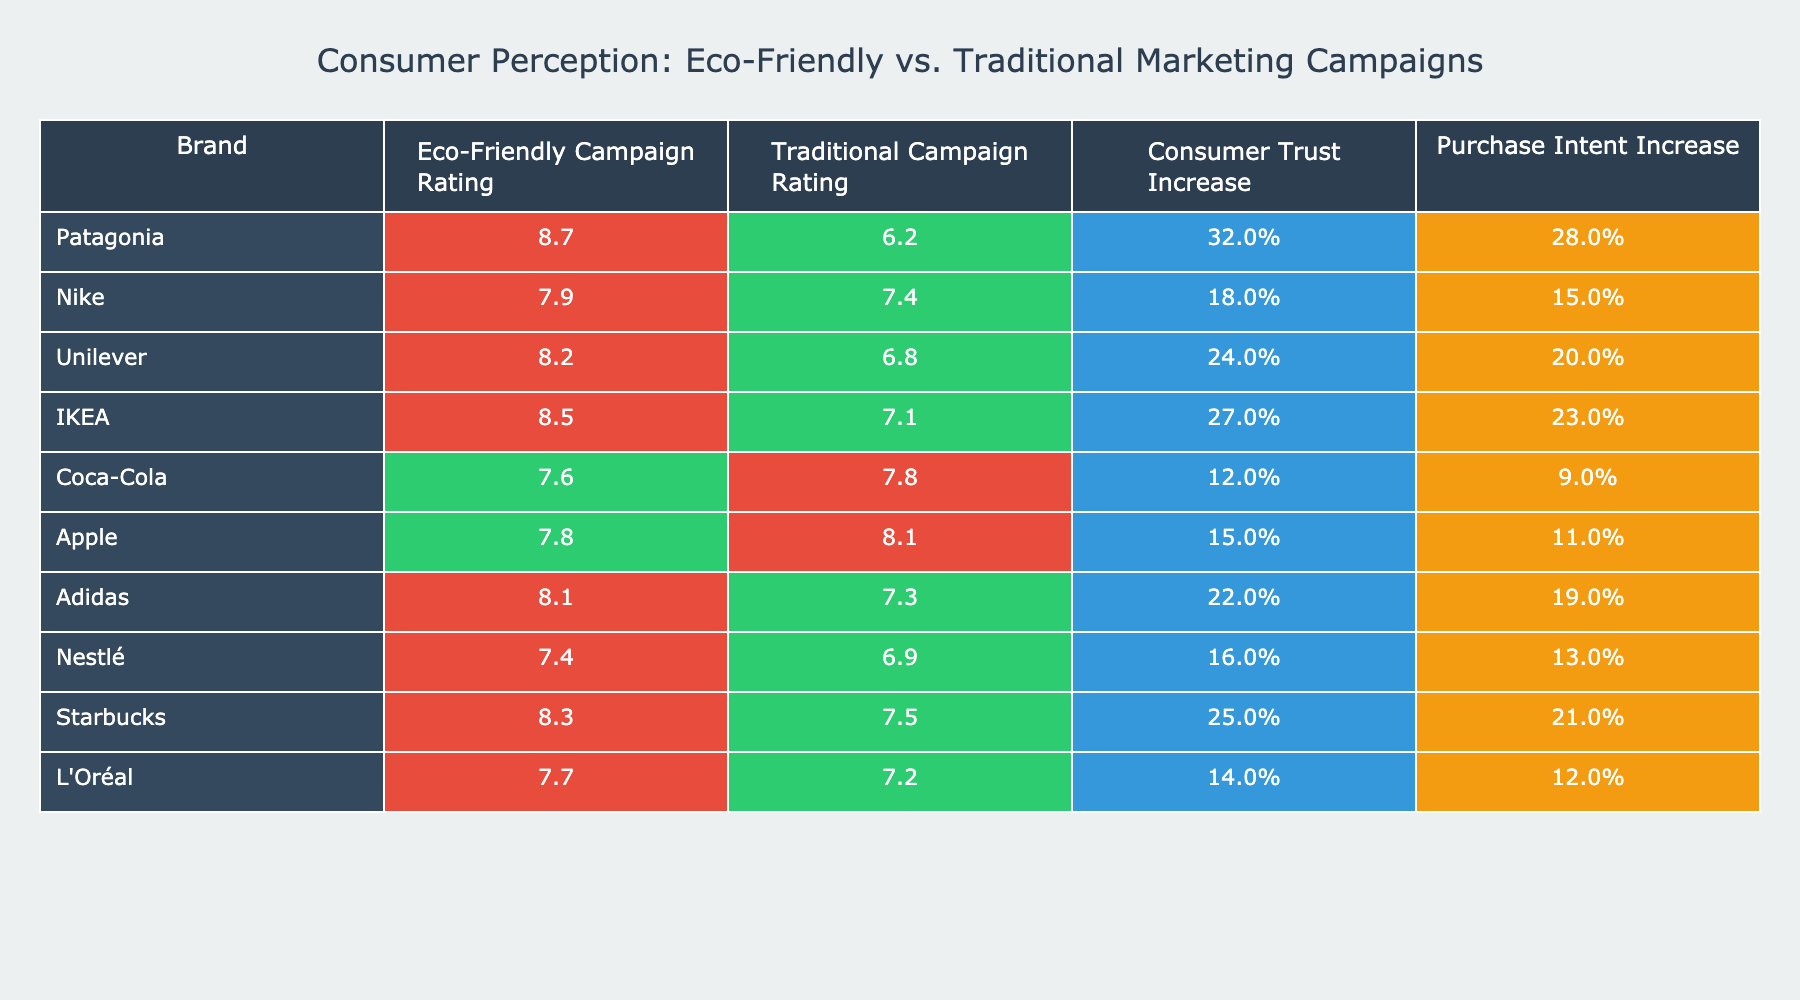What is the highest eco-friendly campaign rating among the brands listed? Looking at the Eco-Friendly Campaign Ratings column, Patagonia has the highest rating at 8.7.
Answer: 8.7 Which brand has the lowest traditional campaign rating, and what is that rating? In the Traditional Campaign Rating column, Coca-Cola has the lowest rating at 7.8.
Answer: Coca-Cola, 7.8 What percentage increase in consumer trust did Unilever's eco-friendly campaign achieve? The Consumer Trust Increase for Unilever's eco-friendly campaign is listed as 24%.
Answer: 24% How much greater is the consumer trust increase for IKEA's eco-friendly campaign compared to Coca-Cola's traditional campaign? IKEA's eco-friendly campaign has a 27% trust increase, while Coca-Cola's traditional campaign has a 12% increase. The difference is 27% - 12% = 15%.
Answer: 15% Which brand saw the greatest increase in purchase intent? In analyzing the Purchase Intent Increase column, Patagonia's eco-friendly campaign increased purchase intent by 28%, which is the greatest amount.
Answer: Patagonia, 28% Which two brands have the closest eco-friendly campaign ratings, and what are these ratings? Looking at the Eco-Friendly Campaign Ratings, Nike (7.9) and Adidas (8.1) have the closest ratings with a difference of only 0.2.
Answer: Nike (7.9), Adidas (8.1) Is there a brand that has a higher rating for its eco-friendly campaign compared to its traditional campaign? Yes, all brands listed except Coca-Cola and Apple show a higher rating for their eco-friendly campaigns than for their traditional campaigns.
Answer: Yes What is the average eco-friendly campaign rating across all brands? The eco-friendly ratings for all brands are 8.7, 7.9, 8.2, 8.5, 7.6, 7.8, 8.1, 7.4, 8.3, and 7.7. The sum of these ratings is 86.2 and there are 10 brands, so the average is 86.2 / 10 = 8.62.
Answer: 8.62 Which brand has the highest disparity between eco-friendly and traditional campaign ratings? Calculating the differences: Patagonia (8.7 - 6.2 = 2.5), Nike (7.9 - 7.4 = 0.5), Unilever (8.2 - 6.8 = 1.4), IKEA (8.5 - 7.1 = 1.4), Coca-Cola (7.6 - 7.8 = -0.2), Apple (7.8 - 8.1 = -0.3), Adidas (8.1 - 7.3 = 0.8), Nestlé (7.4 - 6.9 = 0.5), Starbucks (8.3 - 7.5 = 0.8), L'Oréal (7.7 - 7.2 = 0.5). The highest disparity is 2.5 for Patagonia.
Answer: Patagonia Which brands report an increase in consumer trust for both marketing campaign types? Looking at the Consumer Trust Increase column, brands like Nike, Unilever, IKEA, Adidas, Starbucks, and L'Oréal have reported increases for both their eco-friendly and traditional campaigns.
Answer: Nike, Unilever, IKEA, Adidas, Starbucks, L'Oréal 